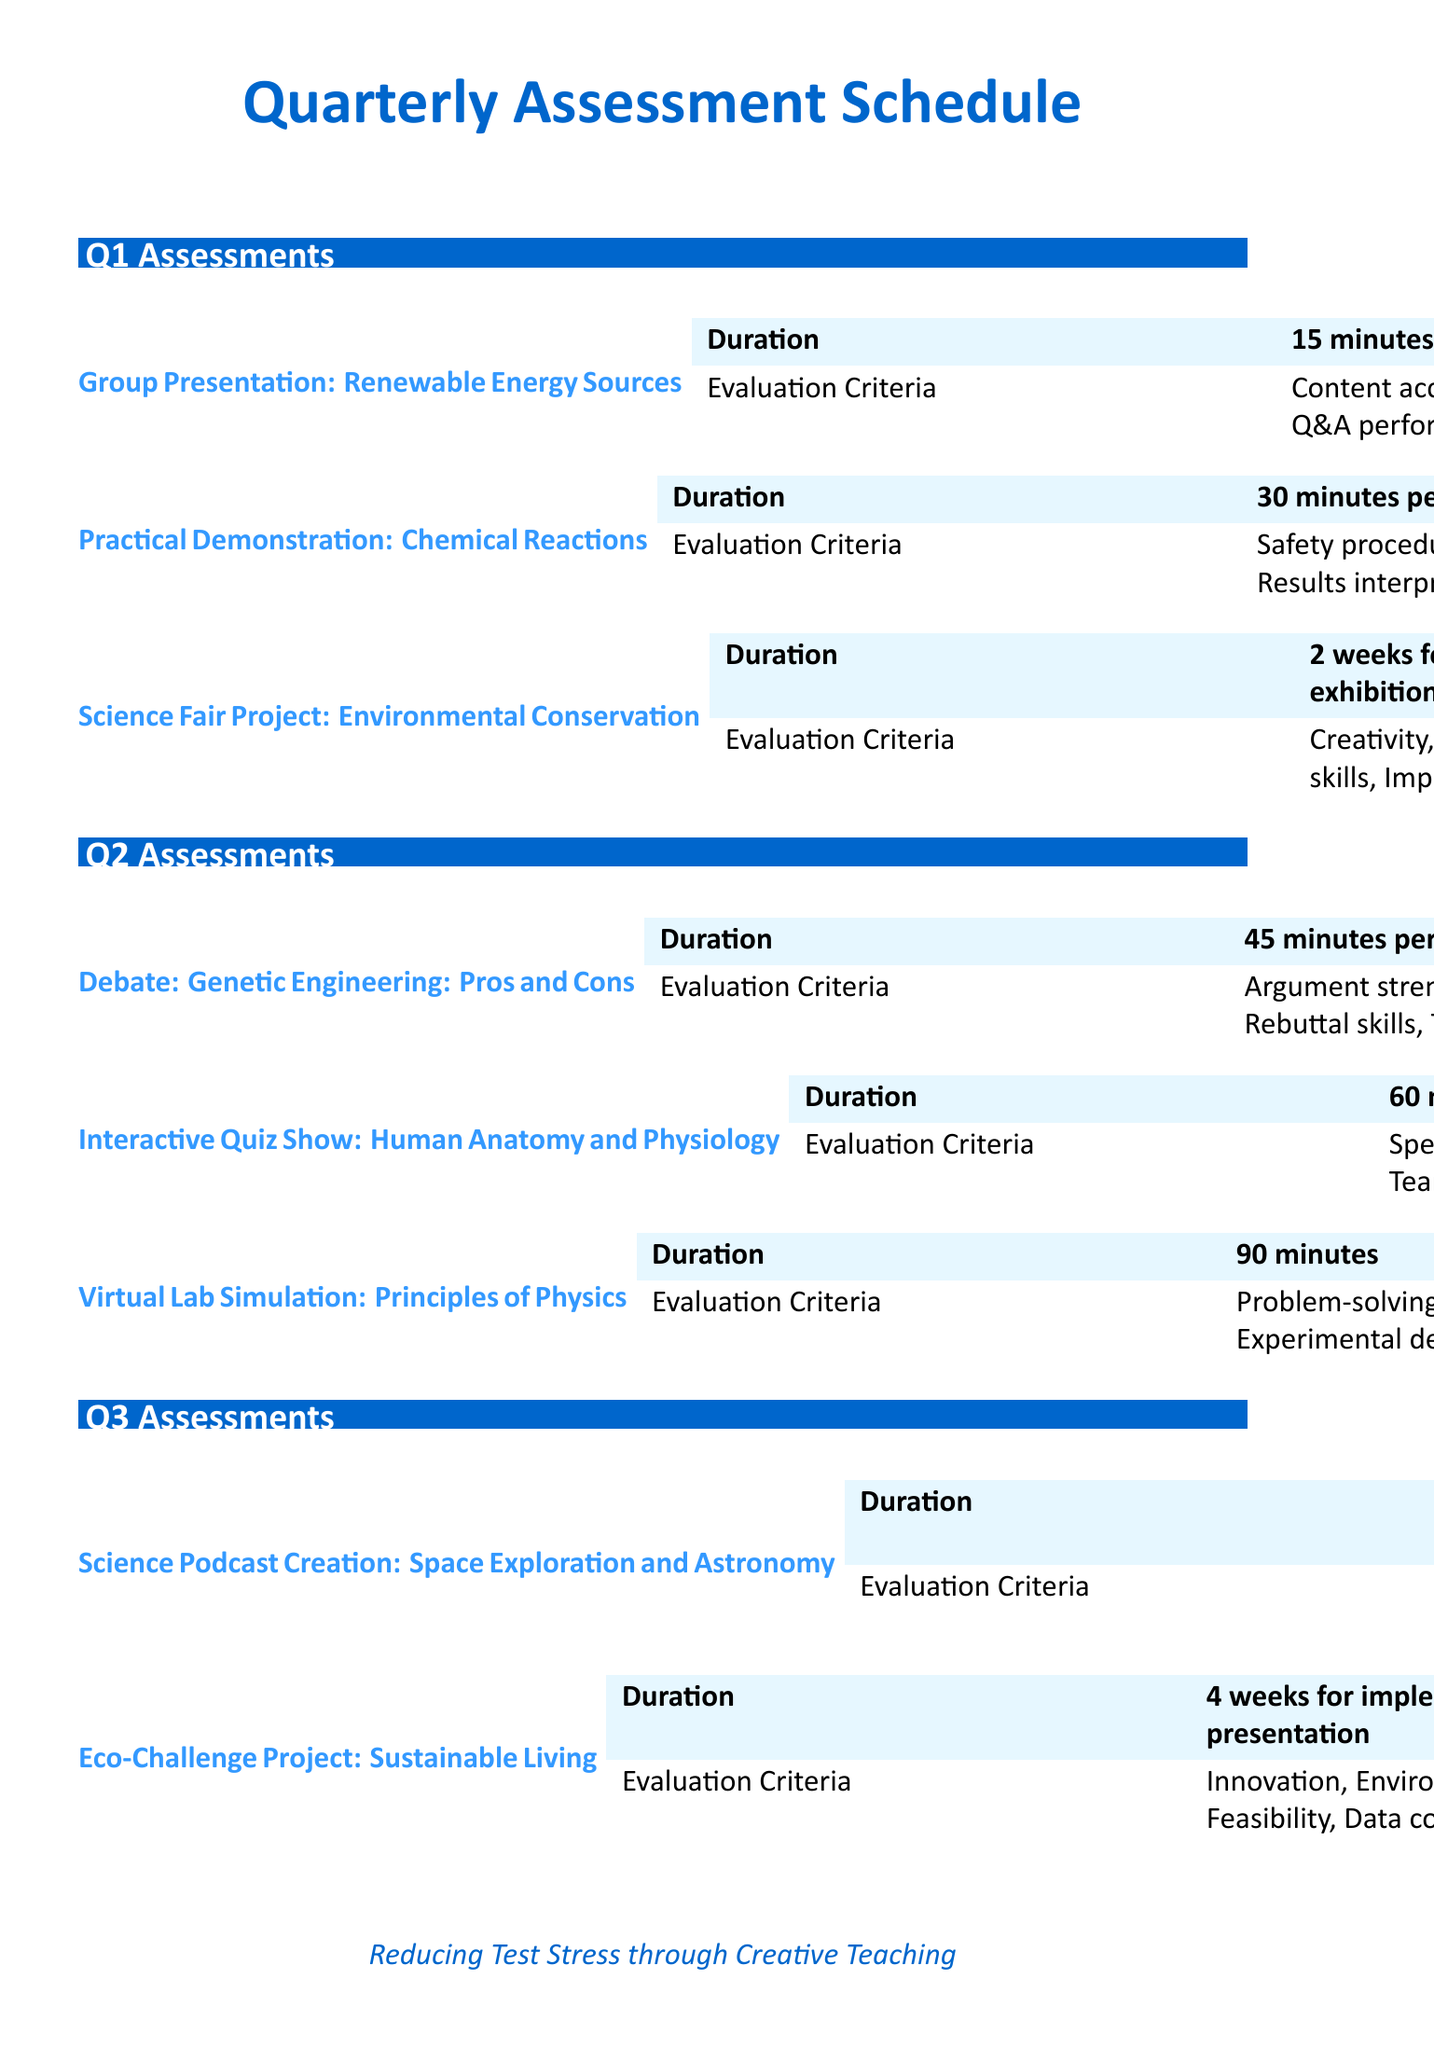What is the topic of the Q1 group presentation? The document lists "Renewable Energy Sources" as the topic for the Q1 group presentation.
Answer: Renewable Energy Sources How long do students have to prepare for the Science Fair Project in Q1? The document states that students have 2 weeks for preparation for the Science Fair Project in Q1.
Answer: 2 weeks What is one evaluation criterion for the TED-style Science Talk in Q4? The document mentions "Content depth" as one of the evaluation criteria for the TED-style Science Talk.
Answer: Content depth What type of assessment does Q3 include that requires a 15-minute podcast? The document describes the "Science Podcast Creation" as the assessment that requires a 15-minute podcast in Q3.
Answer: Science Podcast Creation How long is the duration of the Debate in Q2? According to the document, the duration of the Debate in Q2 is 45 minutes.
Answer: 45 minutes What is the total duration required for the Eco-Challenge Project in Q3? The document states that the Eco-Challenge Project requires 4 weeks for implementation plus 1 day for presentation.
Answer: 4 weeks for implementation, 1 day for presentation What is one strategy mentioned for reducing test-related stress? The document lists "Provide clear rubrics and expectations for each assessment method" as a stress reduction strategy.
Answer: Provide clear rubrics and expectations Which assessment method in Q4 focuses on biodiversity? The document indicates that the "Citizen Science Project" focuses on local biodiversity in Q4.
Answer: Citizen Science Project 